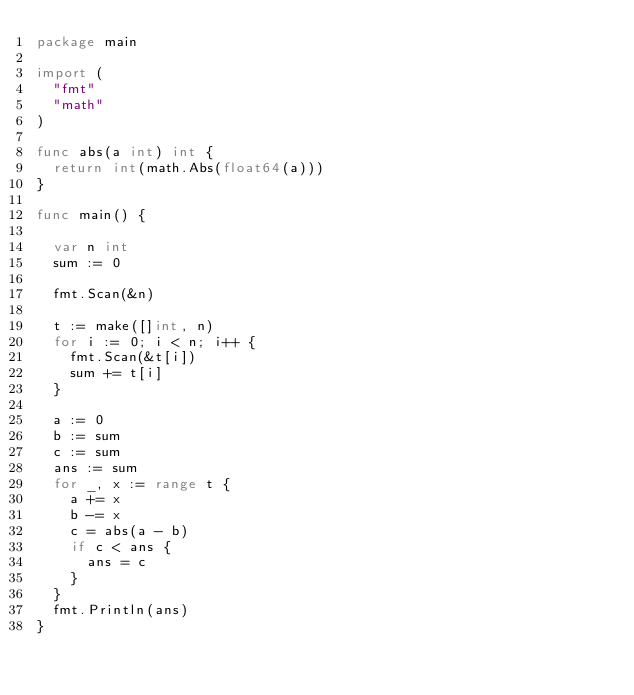Convert code to text. <code><loc_0><loc_0><loc_500><loc_500><_Go_>package main

import (
	"fmt"
	"math"
)

func abs(a int) int {
	return int(math.Abs(float64(a)))
}

func main() {

	var n int
	sum := 0

	fmt.Scan(&n)

	t := make([]int, n)
	for i := 0; i < n; i++ {
		fmt.Scan(&t[i])
		sum += t[i]
	}

	a := 0
	b := sum
	c := sum
	ans := sum
	for _, x := range t {
		a += x
		b -= x
		c = abs(a - b)
		if c < ans {
			ans = c
		}
	}
	fmt.Println(ans)
}
</code> 